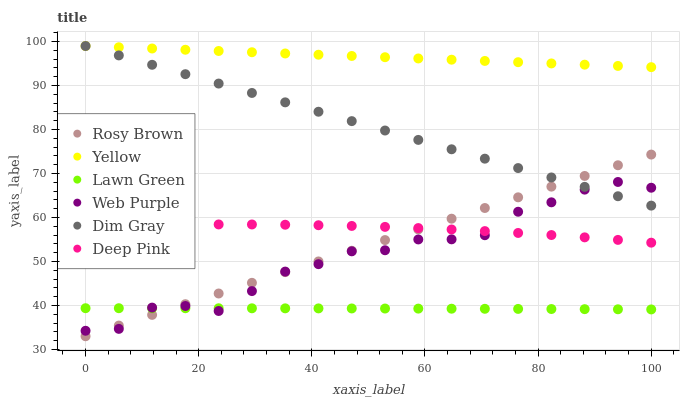Does Lawn Green have the minimum area under the curve?
Answer yes or no. Yes. Does Yellow have the maximum area under the curve?
Answer yes or no. Yes. Does Dim Gray have the minimum area under the curve?
Answer yes or no. No. Does Dim Gray have the maximum area under the curve?
Answer yes or no. No. Is Dim Gray the smoothest?
Answer yes or no. Yes. Is Web Purple the roughest?
Answer yes or no. Yes. Is Rosy Brown the smoothest?
Answer yes or no. No. Is Rosy Brown the roughest?
Answer yes or no. No. Does Rosy Brown have the lowest value?
Answer yes or no. Yes. Does Dim Gray have the lowest value?
Answer yes or no. No. Does Yellow have the highest value?
Answer yes or no. Yes. Does Rosy Brown have the highest value?
Answer yes or no. No. Is Web Purple less than Yellow?
Answer yes or no. Yes. Is Yellow greater than Deep Pink?
Answer yes or no. Yes. Does Web Purple intersect Dim Gray?
Answer yes or no. Yes. Is Web Purple less than Dim Gray?
Answer yes or no. No. Is Web Purple greater than Dim Gray?
Answer yes or no. No. Does Web Purple intersect Yellow?
Answer yes or no. No. 